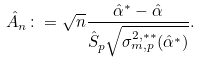<formula> <loc_0><loc_0><loc_500><loc_500>\hat { A } _ { n } \colon = \sqrt { n } \frac { \hat { \alpha } ^ { * } - \hat { \alpha } } { \hat { S } _ { p } \sqrt { \sigma _ { m , p } ^ { 2 , * * } ( \hat { \alpha } ^ { * } ) } } .</formula> 